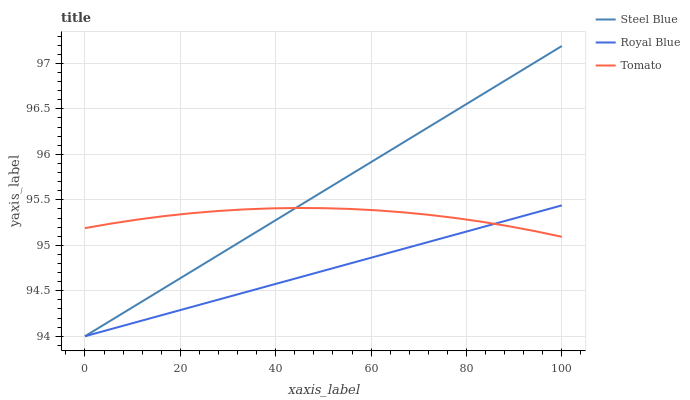Does Steel Blue have the minimum area under the curve?
Answer yes or no. No. Does Royal Blue have the maximum area under the curve?
Answer yes or no. No. Is Royal Blue the smoothest?
Answer yes or no. No. Is Royal Blue the roughest?
Answer yes or no. No. Does Royal Blue have the highest value?
Answer yes or no. No. 